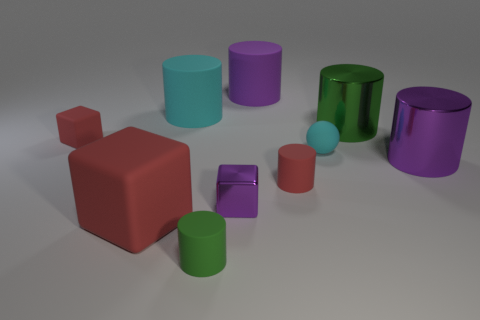Are there any other things that are the same shape as the tiny cyan rubber object?
Keep it short and to the point. No. What number of rubber cylinders are to the left of the small purple object and behind the small rubber block?
Give a very brief answer. 1. Is the material of the cyan object that is on the left side of the small red cylinder the same as the small purple block?
Your answer should be very brief. No. What is the shape of the tiny matte thing on the left side of the big object in front of the metallic cylinder in front of the big green metallic thing?
Your response must be concise. Cube. Are there the same number of tiny green objects that are to the left of the large cube and big matte blocks that are in front of the rubber ball?
Ensure brevity in your answer.  No. There is a rubber cube that is the same size as the rubber sphere; what is its color?
Provide a short and direct response. Red. What number of big objects are either purple things or purple cylinders?
Your response must be concise. 2. What is the cylinder that is on the left side of the tiny purple shiny thing and right of the big cyan rubber object made of?
Your answer should be compact. Rubber. There is a metal thing behind the tiny red rubber cube; does it have the same shape as the purple thing that is behind the tiny ball?
Your answer should be very brief. Yes. There is a large rubber object that is the same color as the matte ball; what is its shape?
Your response must be concise. Cylinder. 